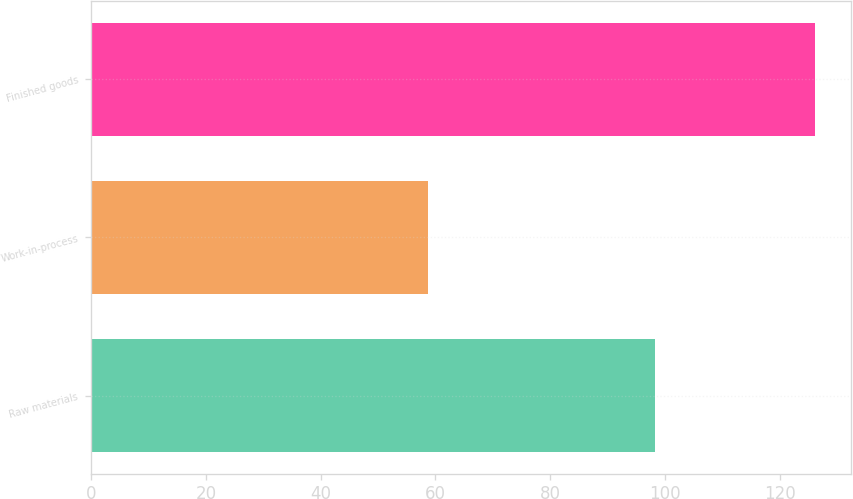Convert chart to OTSL. <chart><loc_0><loc_0><loc_500><loc_500><bar_chart><fcel>Raw materials<fcel>Work-in-process<fcel>Finished goods<nl><fcel>98.3<fcel>58.7<fcel>126.1<nl></chart> 